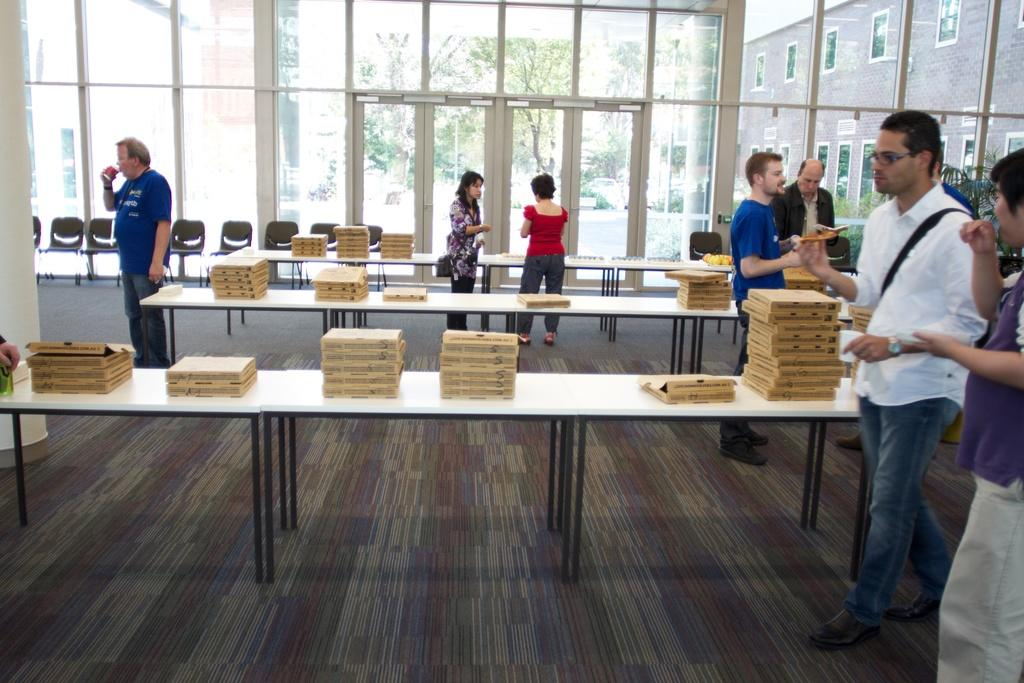How many people are in the image? There are persons standing in the image, but the exact number is not specified. What type of furniture is visible in the image? Chairs and tables are visible in the image. What is on top of the tables? Boxes are on the tables. What can be seen from the windows in the image? Trees and buildings are visible from the windows. Can you tell me how the sidewalk is connected to the building in the image? There is no sidewalk present in the image; it only shows persons, furniture, boxes, and the view from the windows. 